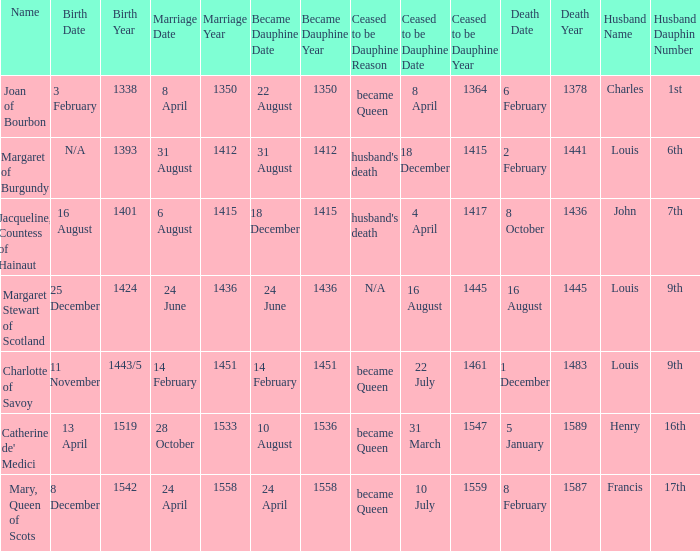When was the marriage when became dauphine is 31 august 1412? 31 August 1412. 